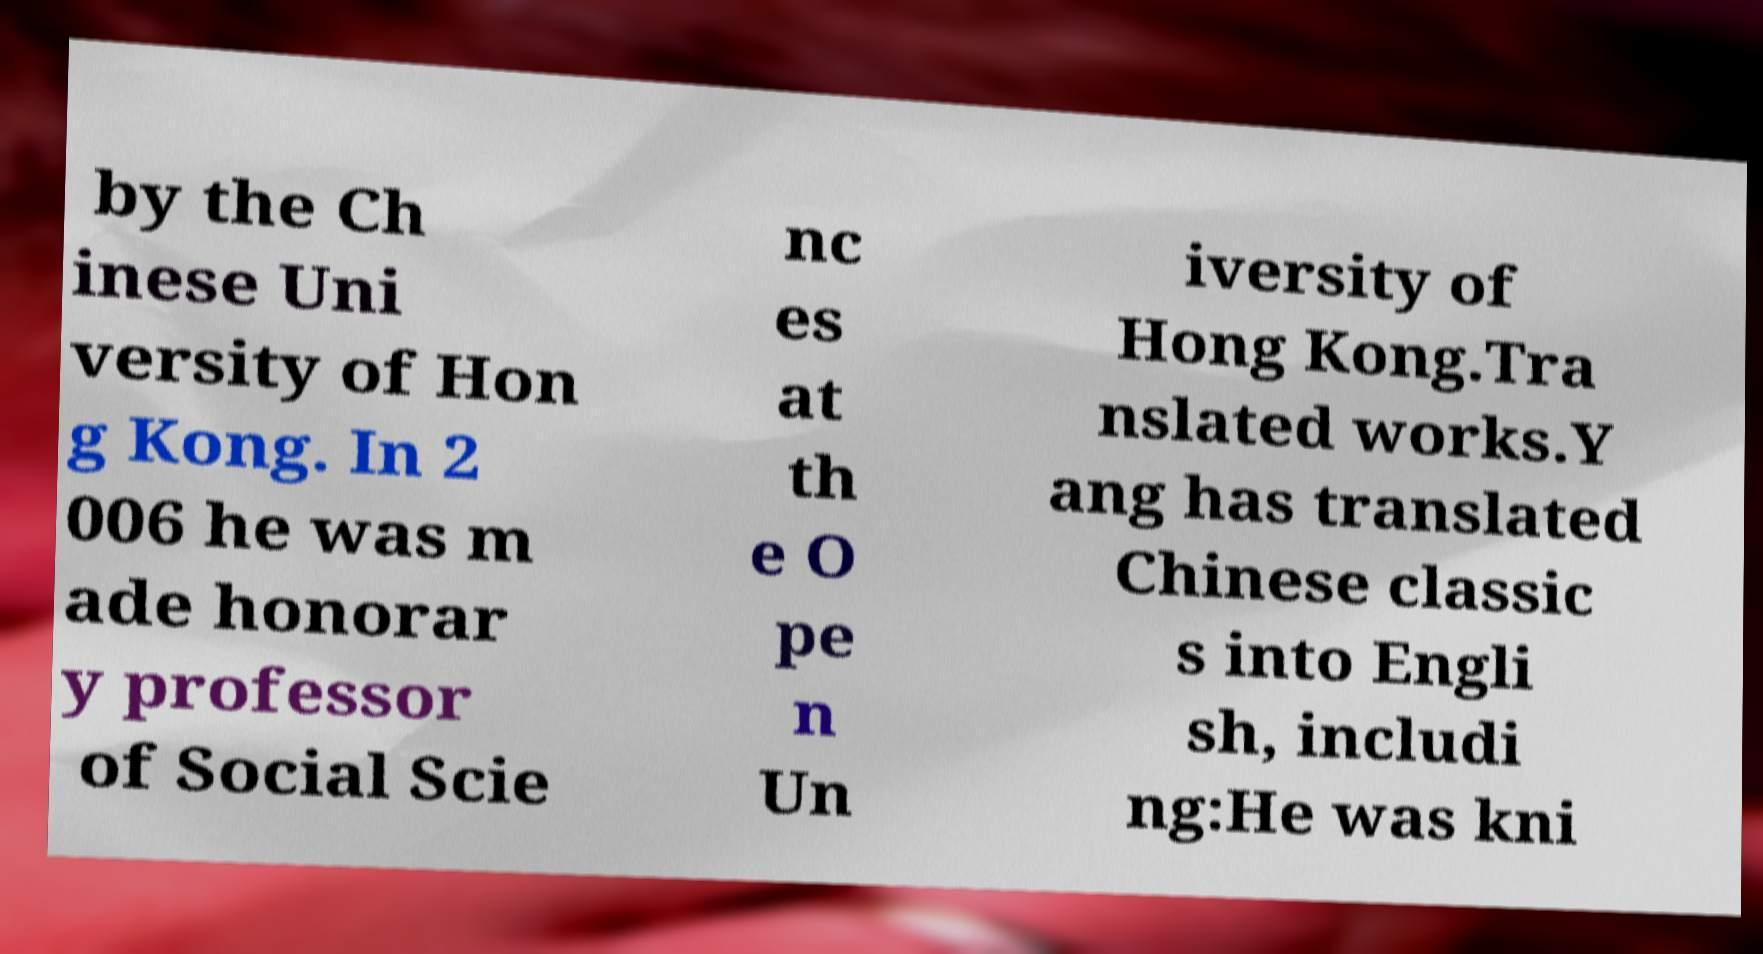I need the written content from this picture converted into text. Can you do that? by the Ch inese Uni versity of Hon g Kong. In 2 006 he was m ade honorar y professor of Social Scie nc es at th e O pe n Un iversity of Hong Kong.Tra nslated works.Y ang has translated Chinese classic s into Engli sh, includi ng:He was kni 